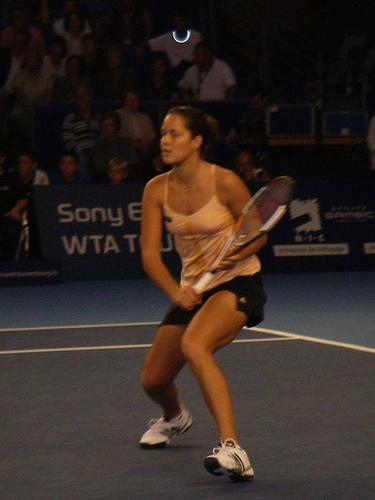What is the woman prepared to do? Please explain your reasoning. swing. She is waiting for the ball to get closer before she hits it 